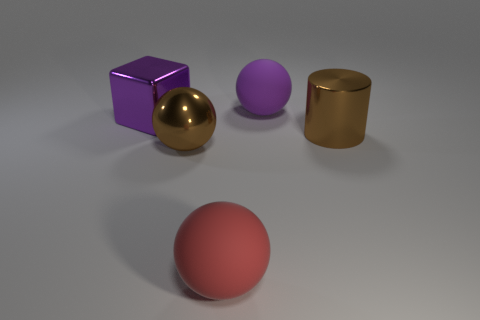How many objects are either large cyan matte cylinders or big things behind the large block?
Ensure brevity in your answer.  1. What color is the matte ball in front of the large metallic object that is to the right of the large rubber thing behind the big cube?
Give a very brief answer. Red. There is a big purple thing that is the same shape as the big red thing; what is its material?
Offer a terse response. Rubber. What color is the large cylinder?
Your response must be concise. Brown. Is the large metallic cylinder the same color as the metallic sphere?
Give a very brief answer. Yes. How many shiny things are gray cylinders or brown spheres?
Your response must be concise. 1. There is a object to the right of the large rubber ball to the right of the large red matte thing; is there a shiny sphere to the left of it?
Provide a succinct answer. Yes. What is the size of the purple object that is made of the same material as the red object?
Your answer should be compact. Large. Are there any brown metal things to the right of the red matte thing?
Provide a short and direct response. Yes. Are there any big cylinders that are in front of the shiny object that is right of the red ball?
Provide a short and direct response. No. 